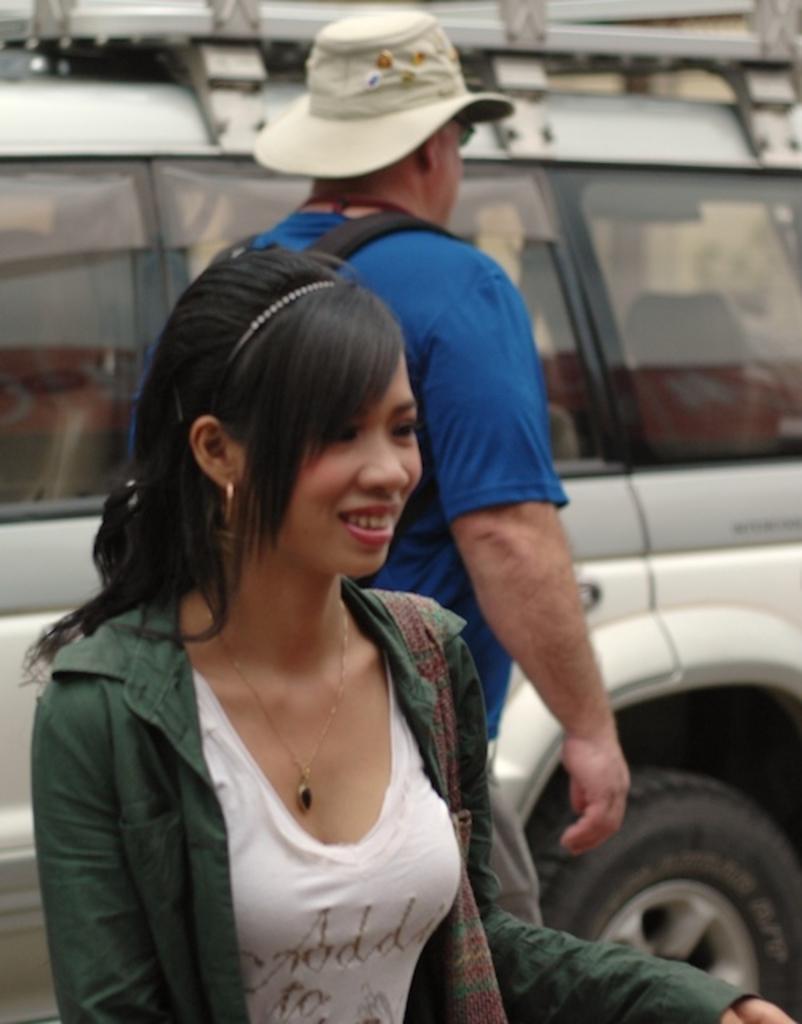Can you describe this image briefly? In this image I can see two persons. And in the background there is a vehicle. 